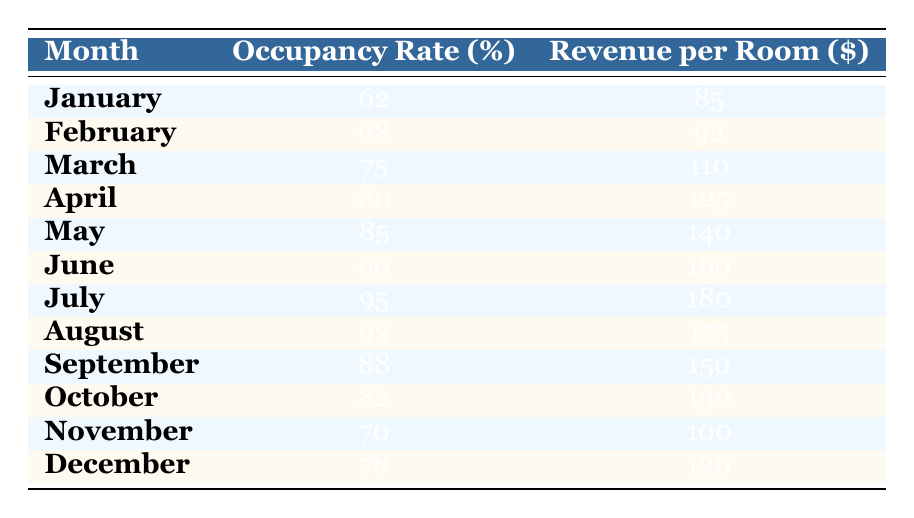What is the highest occupancy rate recorded in the table? The maximum occupancy rate can be found by scanning through the "Occupancy Rate (%)" column to identify the largest value. The highest value in that column is 95, observed in July.
Answer: 95 Which month had the second lowest revenue per room? First, we look at the "Revenue per Room ($)" column and identify the values: 85, 92, 110, 125, 140, 160, 180, 175, 150, 130, 100, and 120. The second lowest revenue is 100, found in November.
Answer: November What is the average occupancy rate for the months of June, July, and August? To find the average: Sum the occupancy rates for those months (90 in June, 95 in July, and 93 in August): 90 + 95 + 93 = 278. Divide by the number of months (3): 278 / 3 = approximately 92.67.
Answer: 92.67 Is the revenue per room for October greater than the average revenue per room of the entire year? First, calculate the average revenue per room for the year. The values are: 85, 92, 110, 125, 140, 160, 180, 175, 150, 130, 100, and 120. Their sum is 1,490, and the average is 1,490 / 12 = approximately 124.17. October's revenue is 130, which is greater than the average.
Answer: Yes What is the total revenue for all months combined? To calculate the total revenue, sum all values in the "Revenue per Room ($)" column: 85 + 92 + 110 + 125 + 140 + 160 + 180 + 175 + 150 + 130 + 100 + 120 = 1,490.
Answer: 1490 How many months had an occupancy rate greater than 80%? Looking at the "Occupancy Rate (%)" column, the months with rates greater than 80% are: April (80), May (85), June (90), July (95), August (93), and September (88). This gives us a total of 6 months.
Answer: 6 